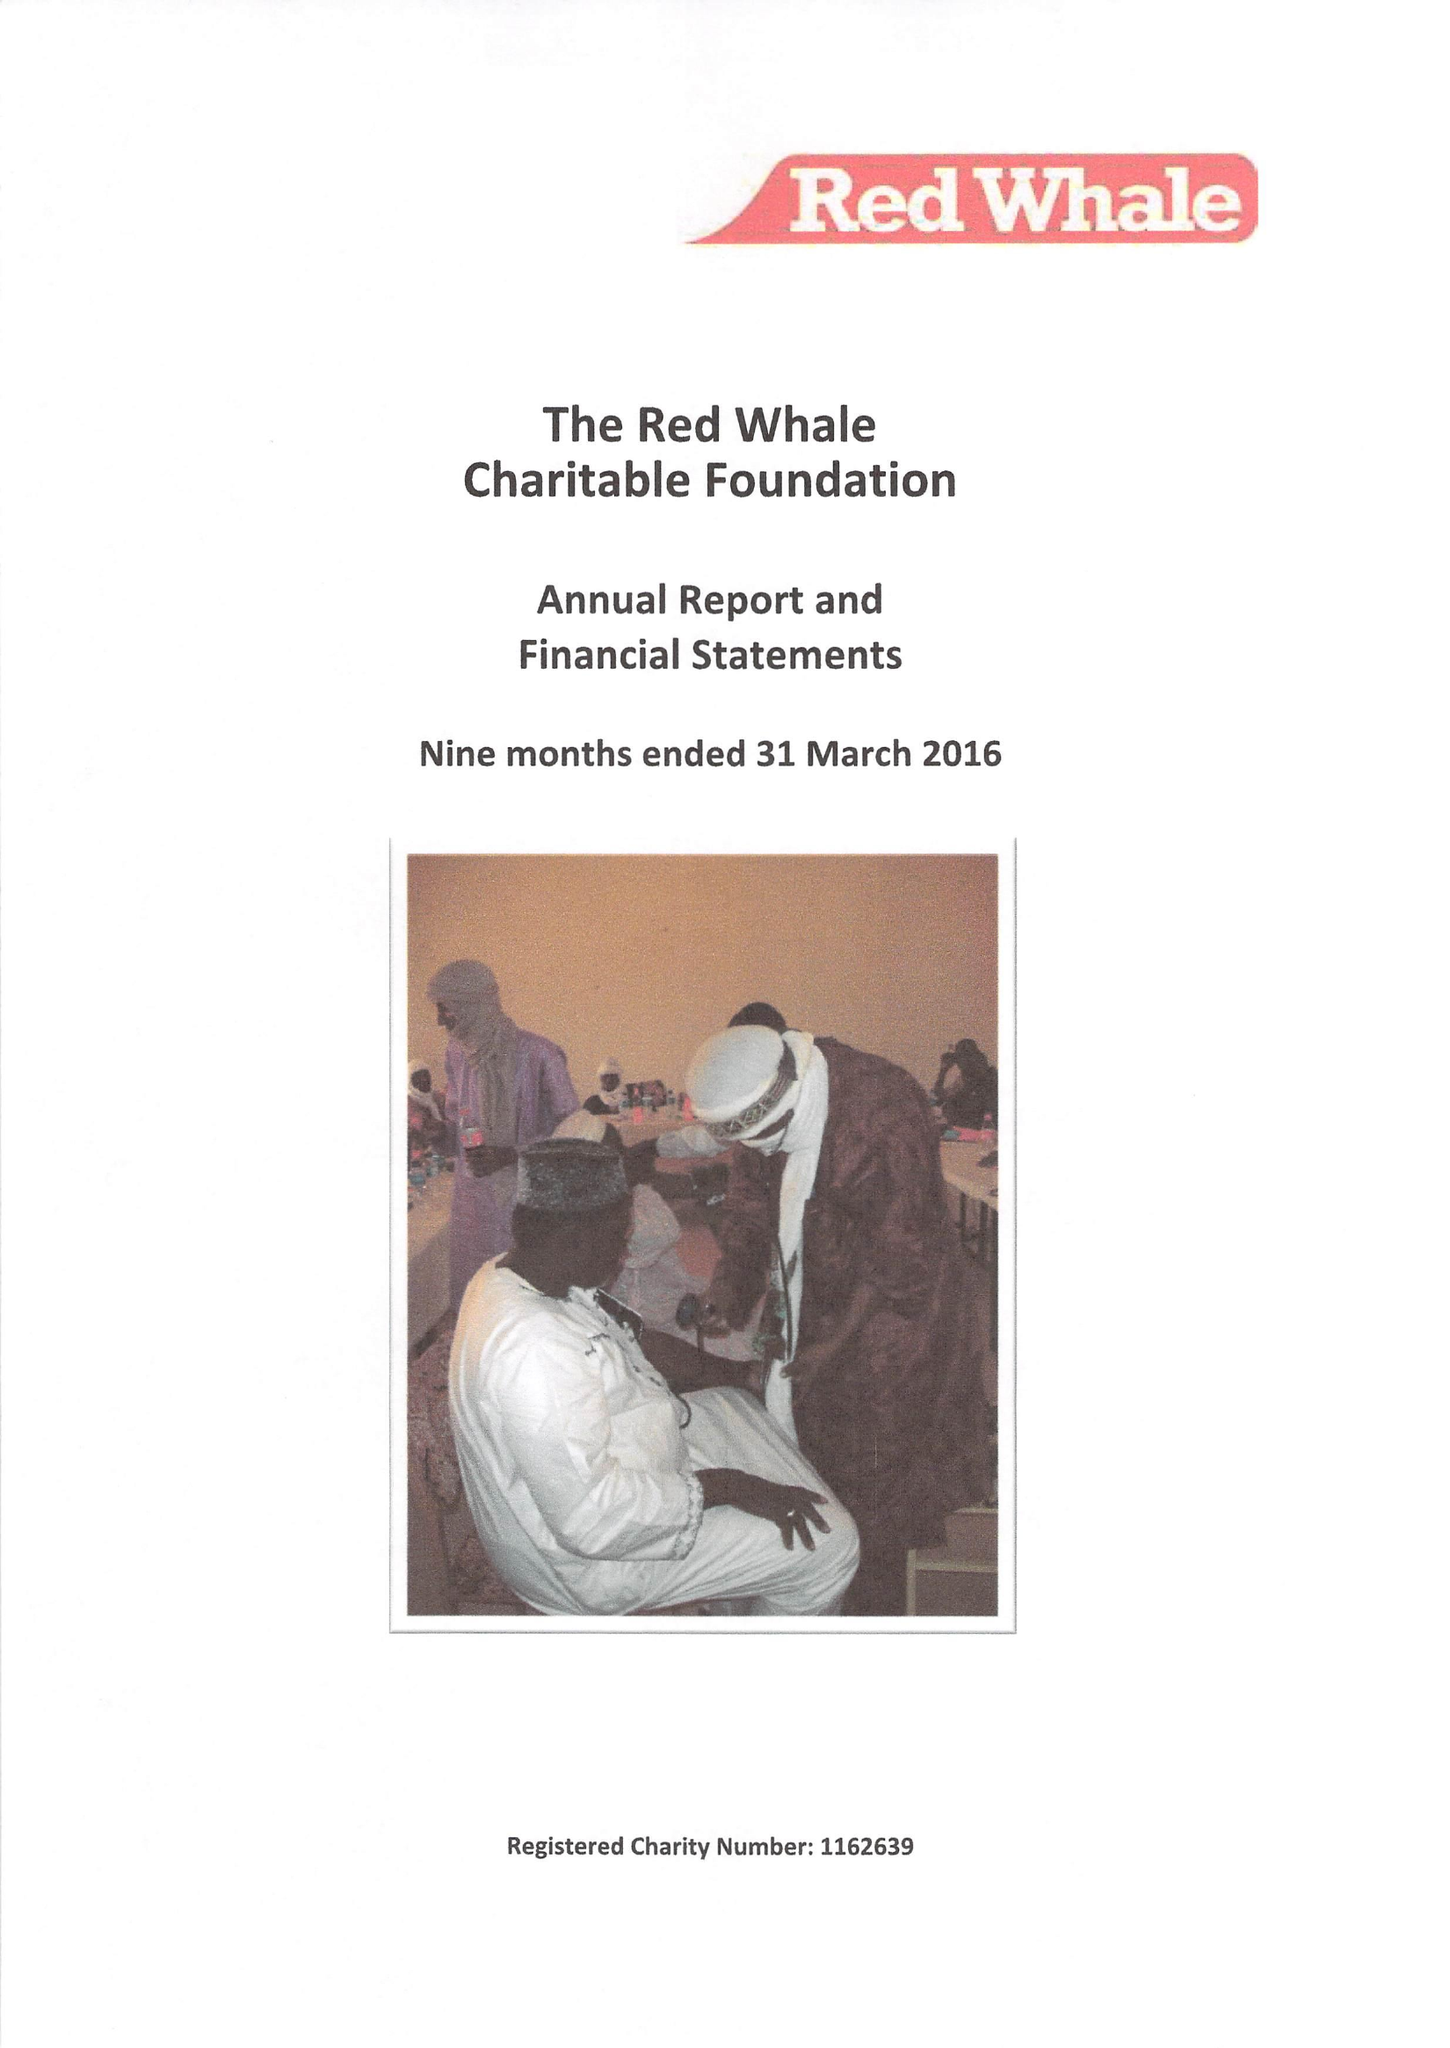What is the value for the spending_annually_in_british_pounds?
Answer the question using a single word or phrase. 480.00 